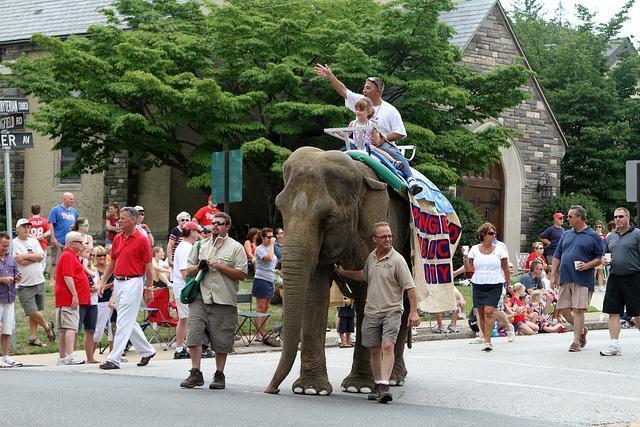How many streets are at this intersection?
Give a very brief answer. 3. How many people can be seen?
Give a very brief answer. 8. 